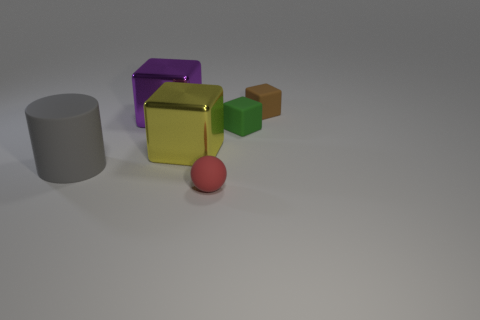Are there any purple metal balls?
Keep it short and to the point. No. What is the material of the small block on the left side of the rubber cube that is behind the tiny matte cube that is in front of the brown matte cube?
Ensure brevity in your answer.  Rubber. There is a green object; is it the same shape as the tiny matte thing in front of the gray object?
Offer a terse response. No. What number of green matte objects are the same shape as the purple metal thing?
Ensure brevity in your answer.  1. The yellow shiny object has what shape?
Your response must be concise. Cube. There is a matte object to the right of the tiny block that is in front of the brown cube; how big is it?
Make the answer very short. Small. What number of objects are either cyan shiny spheres or small green objects?
Make the answer very short. 1. Is the shape of the red object the same as the brown object?
Your answer should be compact. No. Is there a green block made of the same material as the big cylinder?
Your answer should be very brief. Yes. There is a shiny thing left of the big yellow shiny cube; are there any things to the right of it?
Your answer should be very brief. Yes. 